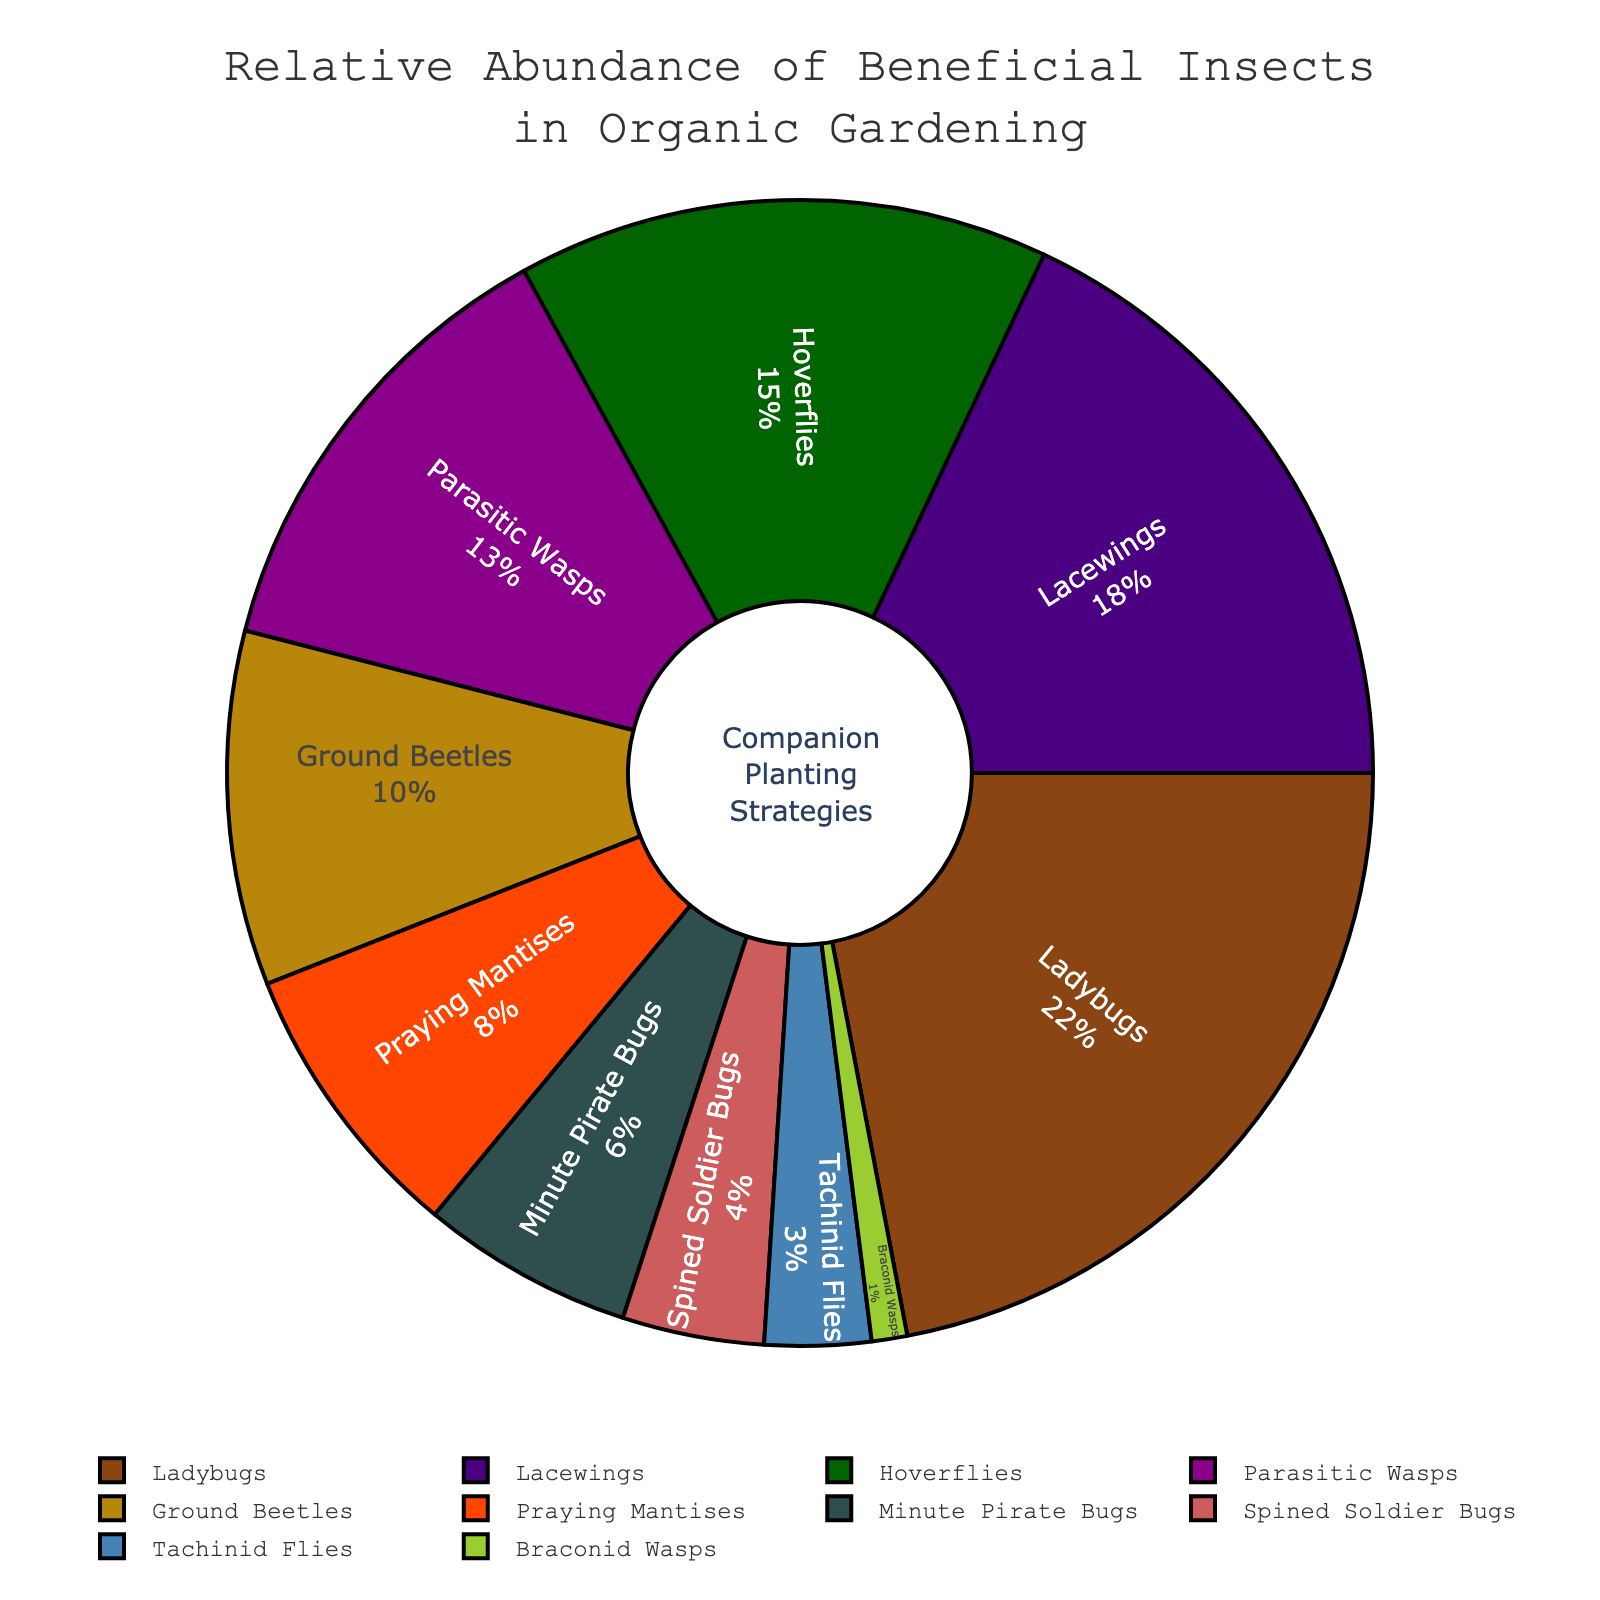What's the most abundant insect species in the pie chart? The most abundant insect species is the one with the highest percentage shown in the pie chart. In this case, the Ladybugs have the highest relative abundance of 22%.
Answer: Ladybugs Which insect species has a higher relative abundance: Lacewings or Hoverflies? To determine which species has a higher relative abundance, compare their percentages. Lacewings have 18%, while Hoverflies have 15%. Lacewings have a higher relative abundance than Hoverflies.
Answer: Lacewings What is the combined relative abundance of Praying Mantises and Minute Pirate Bugs? Sum the relative abundance percentages of Praying Mantises and Minute Pirate Bugs. Praying Mantises are at 8% and Minute Pirate Bugs are at 6%, so the combined relative abundance is 8% + 6% = 14%.
Answer: 14% Are Ladybugs more abundant than the combined abundance of Spined Soldier Bugs and Tachinid Flies? Compare the relative abundance of Ladybugs (22%) with the sum of Spined Soldier Bugs (4%) and Tachinid Flies (3%). The combined abundance of Spined Soldier Bugs and Tachinid Flies is 4% + 3% = 7%. Ladybugs are indeed more abundant than this combined value.
Answer: Yes How much more abundant are Ground Beetles compared to Braconid Wasps? Subtract the relative abundance of Braconid Wasps from Ground Beetles. Ground Beetles have 10% relative abundance while Braconid Wasps have 1%. The difference is 10% - 1% = 9%.
Answer: 9% What is the least represented insect species in the pie chart? The least represented insect species is the one with the smallest percentage. Braconid Wasps have the lowest relative abundance at 1%.
Answer: Braconid Wasps Which insect species are represented with a relative abundance of less than 5%? Identify all species whose relative abundance is less than 5%. These species are Spined Soldier Bugs at 4%, Tachinid Flies at 3%, and Braconid Wasps at 1%.
Answer: Spined Soldier Bugs, Tachinid Flies, Braconid Wasps What’s the total relative abundance of insect species other than Ladybugs? Subtract the relative abundance of Ladybugs from the total (100%). Ladybugs are 22%, so the total for all other species is 100% - 22% = 78%.
Answer: 78% What’s the average relative abundance of Parasitic Wasps, Praying Mantises, and Ground Beetles? To find the average, sum the relative abundance of Parasitic Wasps (13%), Praying Mantises (8%), and Ground Beetles (10%) and then divide by the number of species (3). The sum is 13% + 8% + 10% = 31%. The average is 31% / 3 ≈ 10.33%.
Answer: 10.33% 